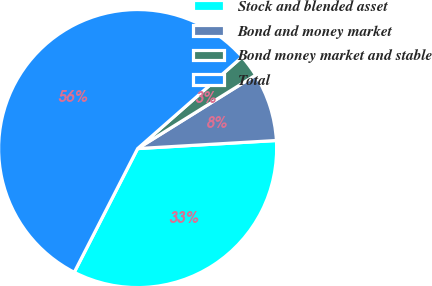Convert chart. <chart><loc_0><loc_0><loc_500><loc_500><pie_chart><fcel>Stock and blended asset<fcel>Bond and money market<fcel>Bond money market and stable<fcel>Total<nl><fcel>33.46%<fcel>7.94%<fcel>2.6%<fcel>56.0%<nl></chart> 